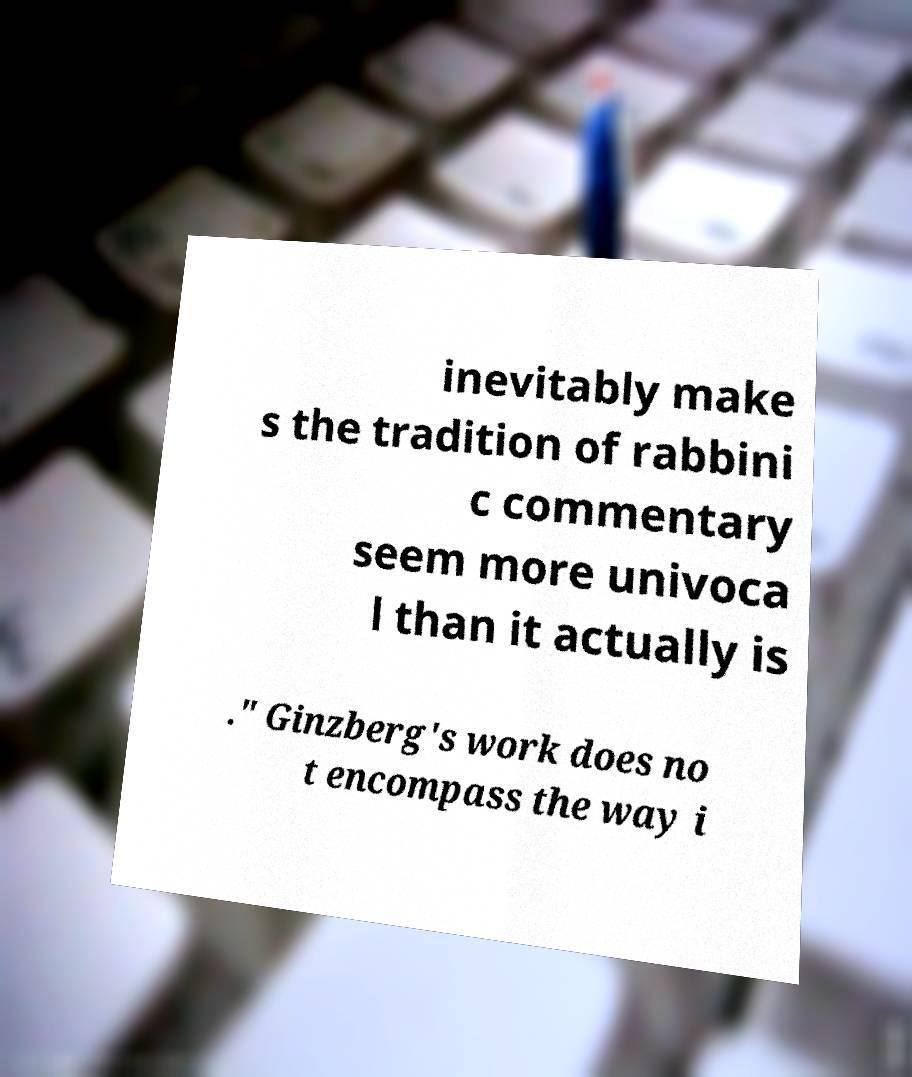There's text embedded in this image that I need extracted. Can you transcribe it verbatim? inevitably make s the tradition of rabbini c commentary seem more univoca l than it actually is ." Ginzberg's work does no t encompass the way i 